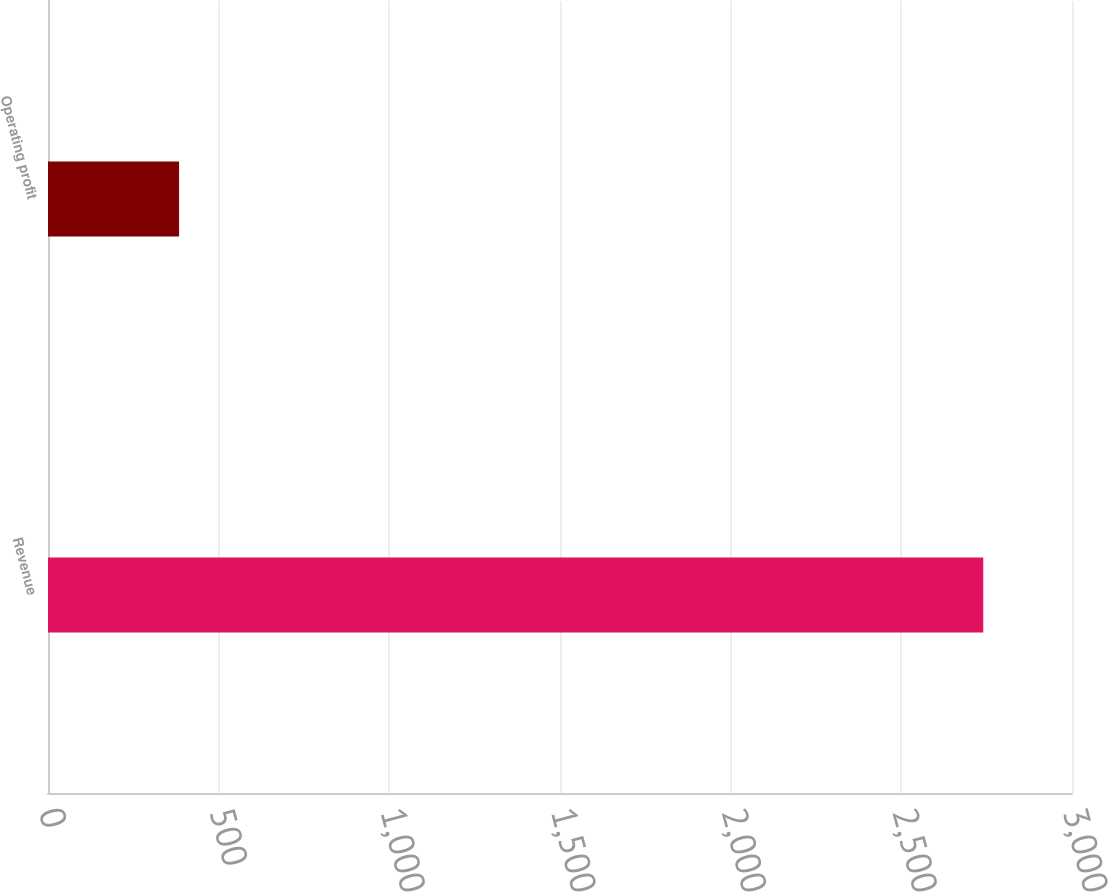Convert chart. <chart><loc_0><loc_0><loc_500><loc_500><bar_chart><fcel>Revenue<fcel>Operating profit<nl><fcel>2740<fcel>384<nl></chart> 